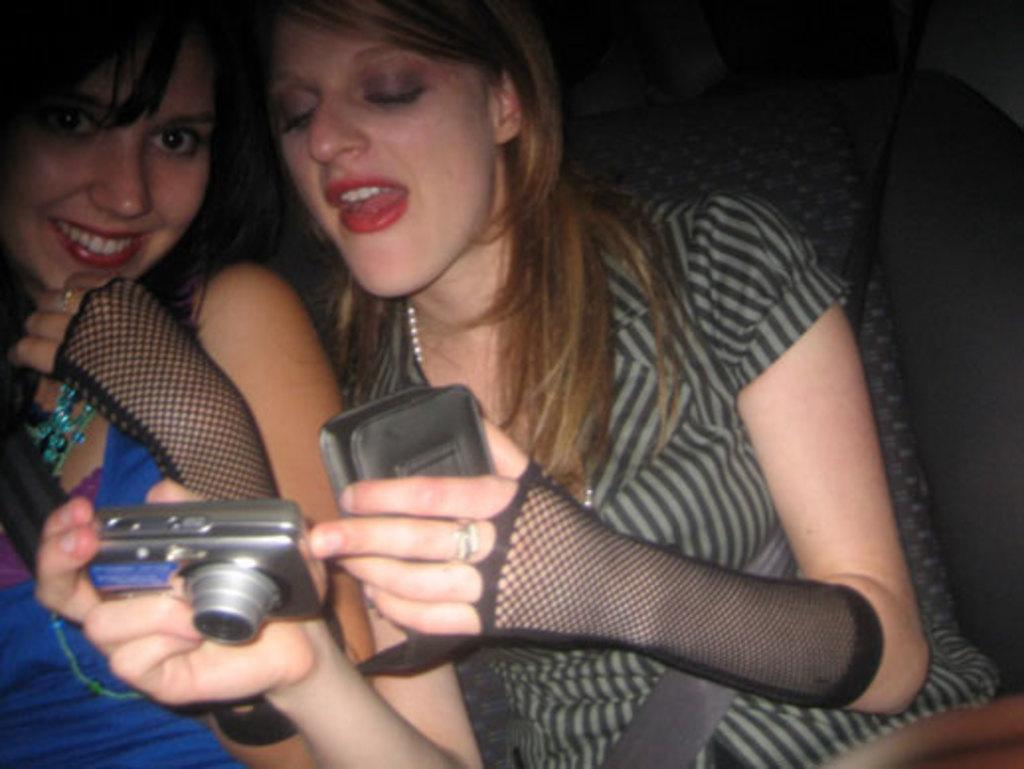How many people are in the image? There are two women in the image. What are the women doing in the image? The women are sitting inside a car and smiling. What is the woman on the left wearing? The woman on the left is wearing a blue dress. What is the woman on the right holding? The woman on the right is holding a camera. What is the woman holding the camera doing? The woman holding the camera is looking at it. Can you see any volcanoes in the image? No, there are no volcanoes present in the image. What type of cloud is visible in the image? There is no cloud visible in the image; it takes place inside a car. 